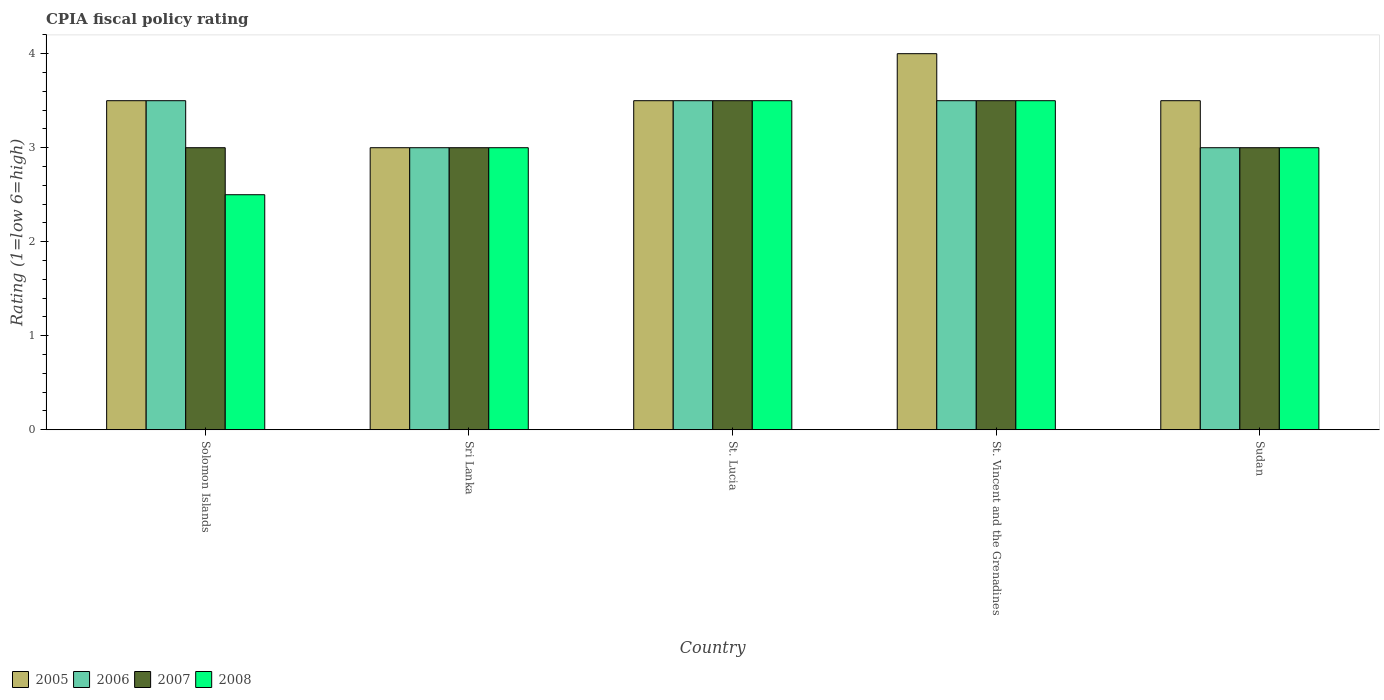How many groups of bars are there?
Your answer should be compact. 5. Are the number of bars per tick equal to the number of legend labels?
Provide a succinct answer. Yes. How many bars are there on the 1st tick from the right?
Make the answer very short. 4. What is the label of the 5th group of bars from the left?
Your answer should be very brief. Sudan. In how many cases, is the number of bars for a given country not equal to the number of legend labels?
Offer a very short reply. 0. What is the CPIA rating in 2007 in St. Lucia?
Keep it short and to the point. 3.5. Across all countries, what is the maximum CPIA rating in 2006?
Provide a succinct answer. 3.5. Across all countries, what is the minimum CPIA rating in 2007?
Your answer should be compact. 3. In which country was the CPIA rating in 2007 maximum?
Your answer should be compact. St. Lucia. In which country was the CPIA rating in 2008 minimum?
Your answer should be very brief. Solomon Islands. What is the total CPIA rating in 2008 in the graph?
Provide a short and direct response. 15.5. What is the difference between the CPIA rating in 2005 in Sri Lanka and that in Sudan?
Offer a very short reply. -0.5. What is the difference between the CPIA rating in 2005 in Sudan and the CPIA rating in 2006 in Solomon Islands?
Keep it short and to the point. 0. What is the average CPIA rating in 2007 per country?
Provide a succinct answer. 3.2. What is the difference between the CPIA rating of/in 2005 and CPIA rating of/in 2008 in St. Lucia?
Ensure brevity in your answer.  0. In how many countries, is the CPIA rating in 2008 greater than 1.8?
Offer a very short reply. 5. What is the ratio of the CPIA rating in 2006 in Sri Lanka to that in St. Vincent and the Grenadines?
Offer a very short reply. 0.86. In how many countries, is the CPIA rating in 2005 greater than the average CPIA rating in 2005 taken over all countries?
Give a very brief answer. 1. Is the sum of the CPIA rating in 2008 in St. Lucia and Sudan greater than the maximum CPIA rating in 2005 across all countries?
Keep it short and to the point. Yes. What does the 1st bar from the right in Solomon Islands represents?
Make the answer very short. 2008. Is it the case that in every country, the sum of the CPIA rating in 2007 and CPIA rating in 2005 is greater than the CPIA rating in 2006?
Give a very brief answer. Yes. How many countries are there in the graph?
Keep it short and to the point. 5. What is the difference between two consecutive major ticks on the Y-axis?
Your answer should be compact. 1. Does the graph contain grids?
Your answer should be very brief. No. Where does the legend appear in the graph?
Keep it short and to the point. Bottom left. How are the legend labels stacked?
Make the answer very short. Horizontal. What is the title of the graph?
Your response must be concise. CPIA fiscal policy rating. Does "2003" appear as one of the legend labels in the graph?
Your answer should be compact. No. What is the label or title of the Y-axis?
Make the answer very short. Rating (1=low 6=high). What is the Rating (1=low 6=high) in 2006 in Solomon Islands?
Your response must be concise. 3.5. What is the Rating (1=low 6=high) of 2008 in Solomon Islands?
Provide a short and direct response. 2.5. What is the Rating (1=low 6=high) in 2005 in Sri Lanka?
Keep it short and to the point. 3. What is the Rating (1=low 6=high) of 2005 in St. Lucia?
Offer a terse response. 3.5. What is the Rating (1=low 6=high) of 2006 in St. Lucia?
Your answer should be very brief. 3.5. What is the Rating (1=low 6=high) in 2007 in St. Lucia?
Keep it short and to the point. 3.5. What is the Rating (1=low 6=high) in 2008 in St. Vincent and the Grenadines?
Ensure brevity in your answer.  3.5. What is the Rating (1=low 6=high) of 2006 in Sudan?
Provide a succinct answer. 3. Across all countries, what is the maximum Rating (1=low 6=high) in 2006?
Offer a very short reply. 3.5. Across all countries, what is the maximum Rating (1=low 6=high) of 2007?
Your answer should be very brief. 3.5. What is the total Rating (1=low 6=high) in 2006 in the graph?
Your response must be concise. 16.5. What is the difference between the Rating (1=low 6=high) in 2005 in Solomon Islands and that in Sri Lanka?
Provide a succinct answer. 0.5. What is the difference between the Rating (1=low 6=high) of 2006 in Solomon Islands and that in Sri Lanka?
Offer a terse response. 0.5. What is the difference between the Rating (1=low 6=high) of 2005 in Solomon Islands and that in St. Lucia?
Your answer should be very brief. 0. What is the difference between the Rating (1=low 6=high) of 2008 in Solomon Islands and that in St. Lucia?
Provide a short and direct response. -1. What is the difference between the Rating (1=low 6=high) in 2005 in Solomon Islands and that in St. Vincent and the Grenadines?
Make the answer very short. -0.5. What is the difference between the Rating (1=low 6=high) of 2006 in Solomon Islands and that in St. Vincent and the Grenadines?
Offer a very short reply. 0. What is the difference between the Rating (1=low 6=high) of 2008 in Solomon Islands and that in St. Vincent and the Grenadines?
Your answer should be very brief. -1. What is the difference between the Rating (1=low 6=high) of 2008 in Solomon Islands and that in Sudan?
Provide a succinct answer. -0.5. What is the difference between the Rating (1=low 6=high) in 2005 in Sri Lanka and that in St. Lucia?
Ensure brevity in your answer.  -0.5. What is the difference between the Rating (1=low 6=high) in 2006 in Sri Lanka and that in St. Lucia?
Your answer should be very brief. -0.5. What is the difference between the Rating (1=low 6=high) in 2008 in Sri Lanka and that in St. Lucia?
Offer a very short reply. -0.5. What is the difference between the Rating (1=low 6=high) in 2006 in Sri Lanka and that in St. Vincent and the Grenadines?
Your answer should be very brief. -0.5. What is the difference between the Rating (1=low 6=high) of 2007 in Sri Lanka and that in St. Vincent and the Grenadines?
Your answer should be compact. -0.5. What is the difference between the Rating (1=low 6=high) in 2005 in Sri Lanka and that in Sudan?
Offer a terse response. -0.5. What is the difference between the Rating (1=low 6=high) in 2008 in Sri Lanka and that in Sudan?
Keep it short and to the point. 0. What is the difference between the Rating (1=low 6=high) of 2005 in St. Lucia and that in St. Vincent and the Grenadines?
Give a very brief answer. -0.5. What is the difference between the Rating (1=low 6=high) of 2008 in St. Lucia and that in St. Vincent and the Grenadines?
Provide a short and direct response. 0. What is the difference between the Rating (1=low 6=high) of 2008 in St. Lucia and that in Sudan?
Your answer should be compact. 0.5. What is the difference between the Rating (1=low 6=high) of 2006 in St. Vincent and the Grenadines and that in Sudan?
Your answer should be compact. 0.5. What is the difference between the Rating (1=low 6=high) in 2006 in Solomon Islands and the Rating (1=low 6=high) in 2008 in Sri Lanka?
Provide a short and direct response. 0.5. What is the difference between the Rating (1=low 6=high) in 2007 in Solomon Islands and the Rating (1=low 6=high) in 2008 in Sri Lanka?
Provide a short and direct response. 0. What is the difference between the Rating (1=low 6=high) in 2005 in Solomon Islands and the Rating (1=low 6=high) in 2007 in St. Lucia?
Provide a short and direct response. 0. What is the difference between the Rating (1=low 6=high) of 2006 in Solomon Islands and the Rating (1=low 6=high) of 2008 in St. Lucia?
Provide a succinct answer. 0. What is the difference between the Rating (1=low 6=high) in 2005 in Solomon Islands and the Rating (1=low 6=high) in 2006 in St. Vincent and the Grenadines?
Your response must be concise. 0. What is the difference between the Rating (1=low 6=high) in 2006 in Solomon Islands and the Rating (1=low 6=high) in 2007 in St. Vincent and the Grenadines?
Offer a terse response. 0. What is the difference between the Rating (1=low 6=high) in 2006 in Solomon Islands and the Rating (1=low 6=high) in 2008 in St. Vincent and the Grenadines?
Ensure brevity in your answer.  0. What is the difference between the Rating (1=low 6=high) of 2006 in Solomon Islands and the Rating (1=low 6=high) of 2007 in Sudan?
Provide a short and direct response. 0.5. What is the difference between the Rating (1=low 6=high) of 2006 in Solomon Islands and the Rating (1=low 6=high) of 2008 in Sudan?
Your answer should be compact. 0.5. What is the difference between the Rating (1=low 6=high) of 2005 in Sri Lanka and the Rating (1=low 6=high) of 2006 in St. Lucia?
Your answer should be very brief. -0.5. What is the difference between the Rating (1=low 6=high) in 2005 in Sri Lanka and the Rating (1=low 6=high) in 2007 in St. Lucia?
Your answer should be very brief. -0.5. What is the difference between the Rating (1=low 6=high) in 2005 in Sri Lanka and the Rating (1=low 6=high) in 2008 in St. Lucia?
Your response must be concise. -0.5. What is the difference between the Rating (1=low 6=high) in 2006 in Sri Lanka and the Rating (1=low 6=high) in 2007 in St. Lucia?
Ensure brevity in your answer.  -0.5. What is the difference between the Rating (1=low 6=high) of 2006 in Sri Lanka and the Rating (1=low 6=high) of 2008 in St. Lucia?
Your answer should be very brief. -0.5. What is the difference between the Rating (1=low 6=high) of 2005 in Sri Lanka and the Rating (1=low 6=high) of 2008 in St. Vincent and the Grenadines?
Ensure brevity in your answer.  -0.5. What is the difference between the Rating (1=low 6=high) in 2006 in Sri Lanka and the Rating (1=low 6=high) in 2008 in St. Vincent and the Grenadines?
Make the answer very short. -0.5. What is the difference between the Rating (1=low 6=high) in 2007 in Sri Lanka and the Rating (1=low 6=high) in 2008 in St. Vincent and the Grenadines?
Ensure brevity in your answer.  -0.5. What is the difference between the Rating (1=low 6=high) in 2005 in Sri Lanka and the Rating (1=low 6=high) in 2007 in Sudan?
Keep it short and to the point. 0. What is the difference between the Rating (1=low 6=high) in 2006 in Sri Lanka and the Rating (1=low 6=high) in 2008 in Sudan?
Keep it short and to the point. 0. What is the difference between the Rating (1=low 6=high) in 2005 in St. Lucia and the Rating (1=low 6=high) in 2007 in St. Vincent and the Grenadines?
Offer a very short reply. 0. What is the difference between the Rating (1=low 6=high) of 2007 in St. Lucia and the Rating (1=low 6=high) of 2008 in St. Vincent and the Grenadines?
Make the answer very short. 0. What is the difference between the Rating (1=low 6=high) in 2005 in St. Lucia and the Rating (1=low 6=high) in 2006 in Sudan?
Provide a succinct answer. 0.5. What is the difference between the Rating (1=low 6=high) of 2005 in St. Lucia and the Rating (1=low 6=high) of 2008 in Sudan?
Offer a very short reply. 0.5. What is the difference between the Rating (1=low 6=high) of 2006 in St. Lucia and the Rating (1=low 6=high) of 2008 in Sudan?
Your response must be concise. 0.5. What is the difference between the Rating (1=low 6=high) in 2005 in St. Vincent and the Grenadines and the Rating (1=low 6=high) in 2006 in Sudan?
Ensure brevity in your answer.  1. What is the difference between the Rating (1=low 6=high) of 2005 in St. Vincent and the Grenadines and the Rating (1=low 6=high) of 2007 in Sudan?
Your answer should be compact. 1. What is the difference between the Rating (1=low 6=high) in 2005 in St. Vincent and the Grenadines and the Rating (1=low 6=high) in 2008 in Sudan?
Provide a short and direct response. 1. What is the difference between the Rating (1=low 6=high) in 2007 in St. Vincent and the Grenadines and the Rating (1=low 6=high) in 2008 in Sudan?
Make the answer very short. 0.5. What is the average Rating (1=low 6=high) in 2006 per country?
Make the answer very short. 3.3. What is the average Rating (1=low 6=high) of 2008 per country?
Offer a terse response. 3.1. What is the difference between the Rating (1=low 6=high) of 2005 and Rating (1=low 6=high) of 2006 in Solomon Islands?
Your answer should be very brief. 0. What is the difference between the Rating (1=low 6=high) in 2005 and Rating (1=low 6=high) in 2008 in Solomon Islands?
Ensure brevity in your answer.  1. What is the difference between the Rating (1=low 6=high) of 2006 and Rating (1=low 6=high) of 2008 in Solomon Islands?
Your answer should be compact. 1. What is the difference between the Rating (1=low 6=high) in 2007 and Rating (1=low 6=high) in 2008 in Solomon Islands?
Your answer should be compact. 0.5. What is the difference between the Rating (1=low 6=high) of 2005 and Rating (1=low 6=high) of 2008 in Sri Lanka?
Make the answer very short. 0. What is the difference between the Rating (1=low 6=high) in 2006 and Rating (1=low 6=high) in 2008 in Sri Lanka?
Your response must be concise. 0. What is the difference between the Rating (1=low 6=high) in 2005 and Rating (1=low 6=high) in 2007 in St. Lucia?
Offer a terse response. 0. What is the difference between the Rating (1=low 6=high) in 2006 and Rating (1=low 6=high) in 2007 in St. Lucia?
Provide a short and direct response. 0. What is the difference between the Rating (1=low 6=high) in 2005 and Rating (1=low 6=high) in 2007 in St. Vincent and the Grenadines?
Provide a succinct answer. 0.5. What is the difference between the Rating (1=low 6=high) in 2005 and Rating (1=low 6=high) in 2008 in Sudan?
Your answer should be very brief. 0.5. What is the difference between the Rating (1=low 6=high) of 2006 and Rating (1=low 6=high) of 2007 in Sudan?
Provide a succinct answer. 0. What is the difference between the Rating (1=low 6=high) in 2006 and Rating (1=low 6=high) in 2008 in Sudan?
Keep it short and to the point. 0. What is the difference between the Rating (1=low 6=high) of 2007 and Rating (1=low 6=high) of 2008 in Sudan?
Ensure brevity in your answer.  0. What is the ratio of the Rating (1=low 6=high) in 2005 in Solomon Islands to that in Sri Lanka?
Keep it short and to the point. 1.17. What is the ratio of the Rating (1=low 6=high) of 2007 in Solomon Islands to that in St. Lucia?
Provide a succinct answer. 0.86. What is the ratio of the Rating (1=low 6=high) in 2007 in Solomon Islands to that in St. Vincent and the Grenadines?
Keep it short and to the point. 0.86. What is the ratio of the Rating (1=low 6=high) in 2008 in Solomon Islands to that in St. Vincent and the Grenadines?
Your answer should be compact. 0.71. What is the ratio of the Rating (1=low 6=high) in 2005 in Solomon Islands to that in Sudan?
Your answer should be compact. 1. What is the ratio of the Rating (1=low 6=high) of 2008 in Solomon Islands to that in Sudan?
Your response must be concise. 0.83. What is the ratio of the Rating (1=low 6=high) in 2005 in Sri Lanka to that in St. Lucia?
Give a very brief answer. 0.86. What is the ratio of the Rating (1=low 6=high) of 2006 in Sri Lanka to that in St. Lucia?
Offer a terse response. 0.86. What is the ratio of the Rating (1=low 6=high) in 2005 in Sri Lanka to that in St. Vincent and the Grenadines?
Provide a short and direct response. 0.75. What is the ratio of the Rating (1=low 6=high) in 2006 in Sri Lanka to that in St. Vincent and the Grenadines?
Make the answer very short. 0.86. What is the ratio of the Rating (1=low 6=high) of 2007 in Sri Lanka to that in St. Vincent and the Grenadines?
Offer a terse response. 0.86. What is the ratio of the Rating (1=low 6=high) in 2008 in Sri Lanka to that in St. Vincent and the Grenadines?
Provide a short and direct response. 0.86. What is the ratio of the Rating (1=low 6=high) in 2006 in Sri Lanka to that in Sudan?
Keep it short and to the point. 1. What is the ratio of the Rating (1=low 6=high) of 2007 in Sri Lanka to that in Sudan?
Give a very brief answer. 1. What is the ratio of the Rating (1=low 6=high) in 2008 in Sri Lanka to that in Sudan?
Make the answer very short. 1. What is the ratio of the Rating (1=low 6=high) in 2005 in St. Lucia to that in St. Vincent and the Grenadines?
Your response must be concise. 0.88. What is the ratio of the Rating (1=low 6=high) in 2006 in St. Lucia to that in St. Vincent and the Grenadines?
Make the answer very short. 1. What is the ratio of the Rating (1=low 6=high) of 2008 in St. Lucia to that in St. Vincent and the Grenadines?
Give a very brief answer. 1. What is the ratio of the Rating (1=low 6=high) of 2006 in St. Lucia to that in Sudan?
Your answer should be very brief. 1.17. What is the ratio of the Rating (1=low 6=high) in 2007 in St. Lucia to that in Sudan?
Provide a succinct answer. 1.17. What is the ratio of the Rating (1=low 6=high) in 2008 in St. Lucia to that in Sudan?
Give a very brief answer. 1.17. What is the ratio of the Rating (1=low 6=high) of 2006 in St. Vincent and the Grenadines to that in Sudan?
Provide a succinct answer. 1.17. What is the difference between the highest and the second highest Rating (1=low 6=high) in 2005?
Offer a very short reply. 0.5. What is the difference between the highest and the second highest Rating (1=low 6=high) of 2007?
Offer a very short reply. 0. What is the difference between the highest and the second highest Rating (1=low 6=high) of 2008?
Provide a succinct answer. 0. What is the difference between the highest and the lowest Rating (1=low 6=high) of 2005?
Your answer should be very brief. 1. What is the difference between the highest and the lowest Rating (1=low 6=high) of 2006?
Provide a succinct answer. 0.5. 